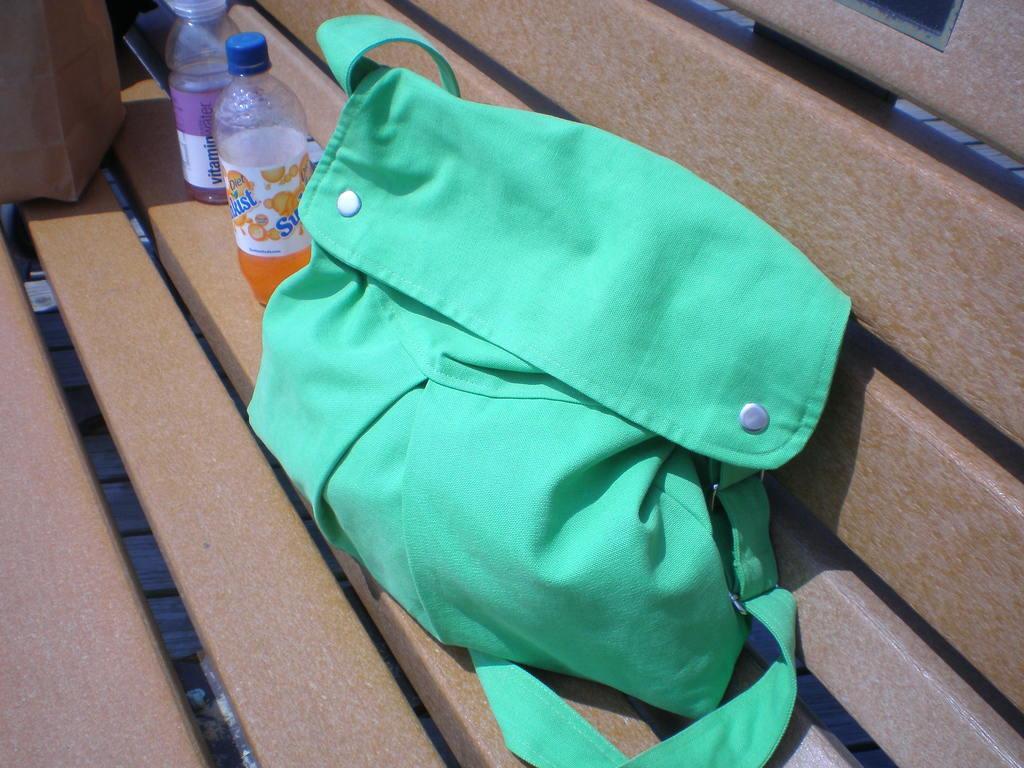Can you describe this image briefly? In this picture we can see a green color bag with belt to it and aside to this bag we have bottles with drink in it, box and this are placed on a bench. 